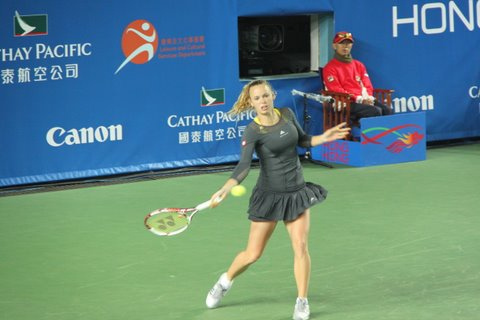Read and extract the text from this image. CATHAY HAY NON C PACIFIC 